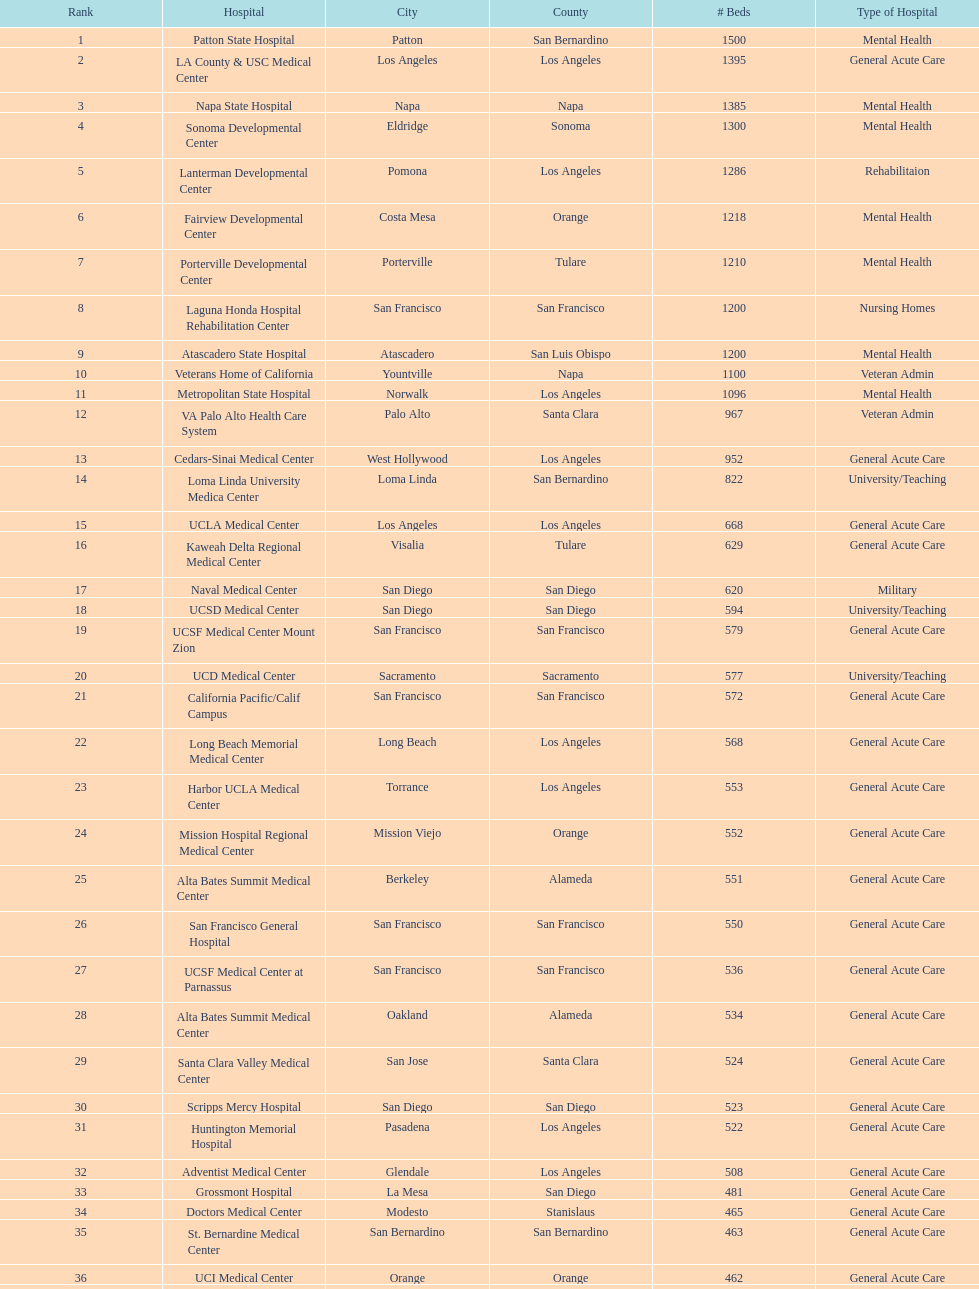How many hospitals have at least 1,000 beds? 11. 